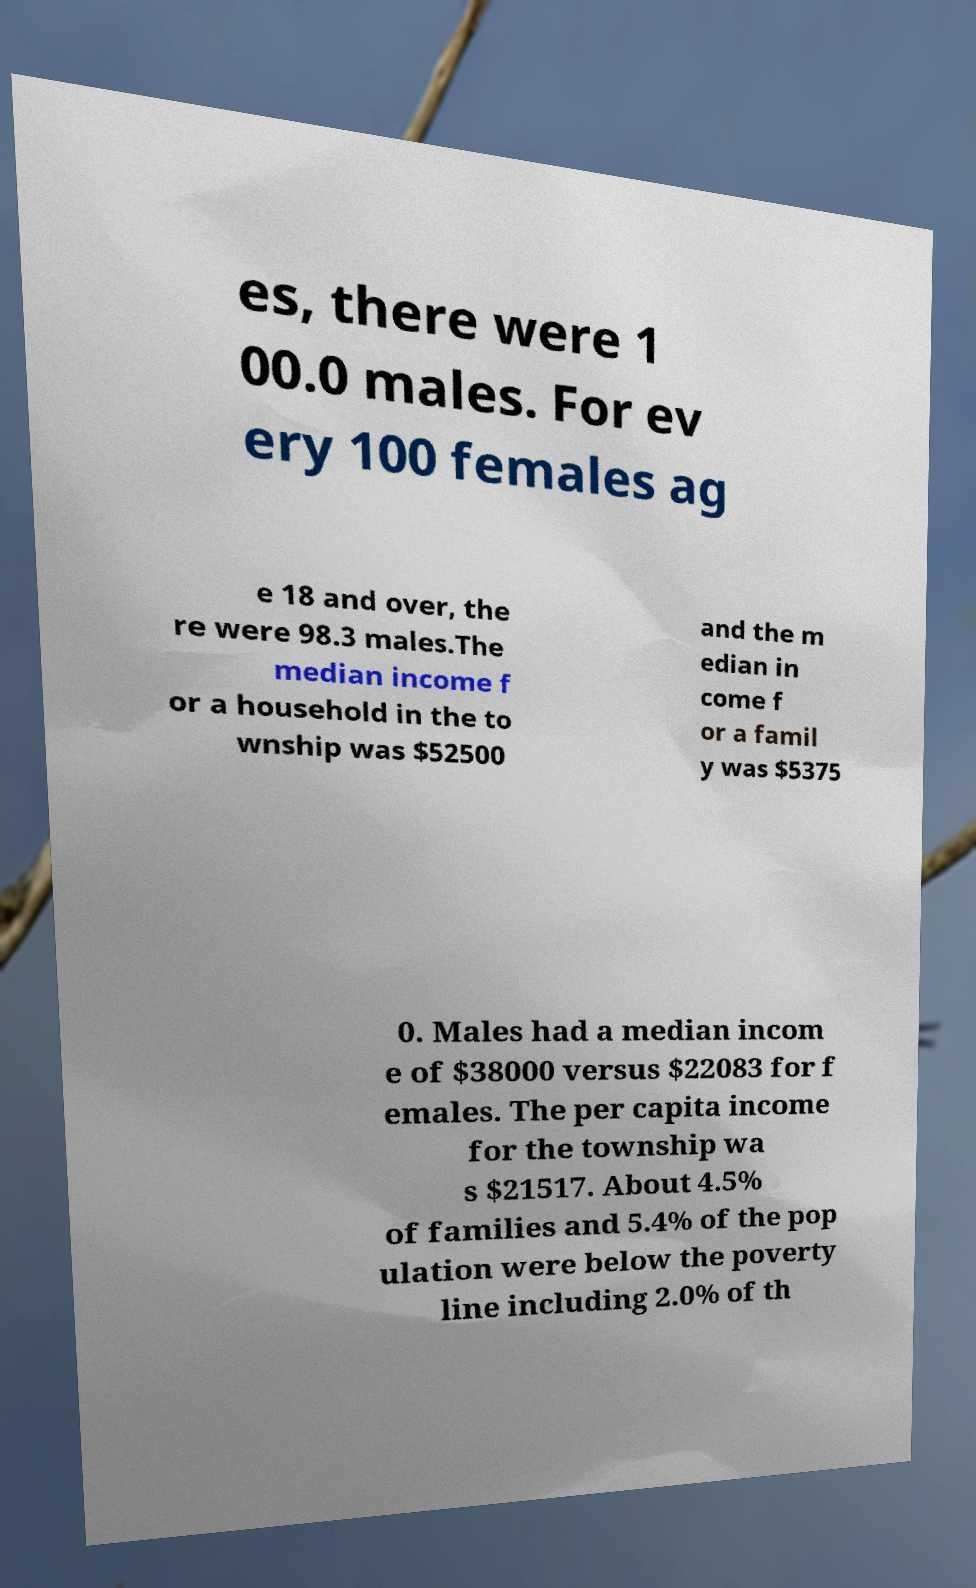Could you assist in decoding the text presented in this image and type it out clearly? es, there were 1 00.0 males. For ev ery 100 females ag e 18 and over, the re were 98.3 males.The median income f or a household in the to wnship was $52500 and the m edian in come f or a famil y was $5375 0. Males had a median incom e of $38000 versus $22083 for f emales. The per capita income for the township wa s $21517. About 4.5% of families and 5.4% of the pop ulation were below the poverty line including 2.0% of th 